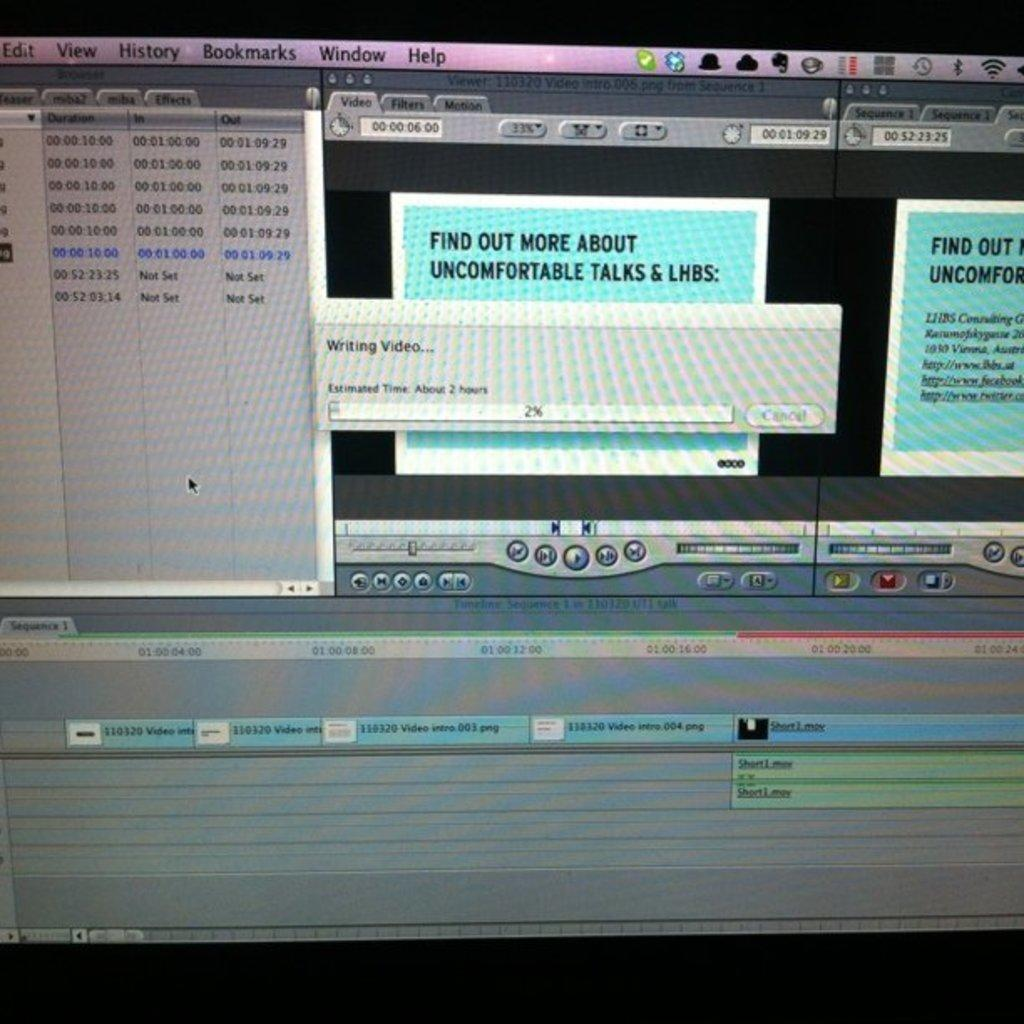<image>
Render a clear and concise summary of the photo. A screen that shows information about uncomfortable talks. 